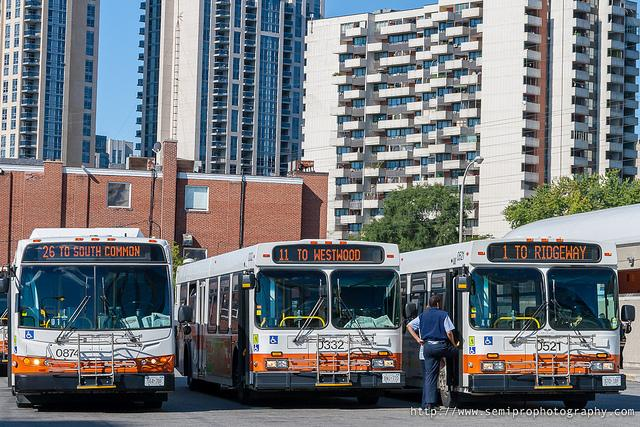The man standing near the buses is probably there to do what?

Choices:
A) get directions
B) travel
C) drive
D) sight-see drive 